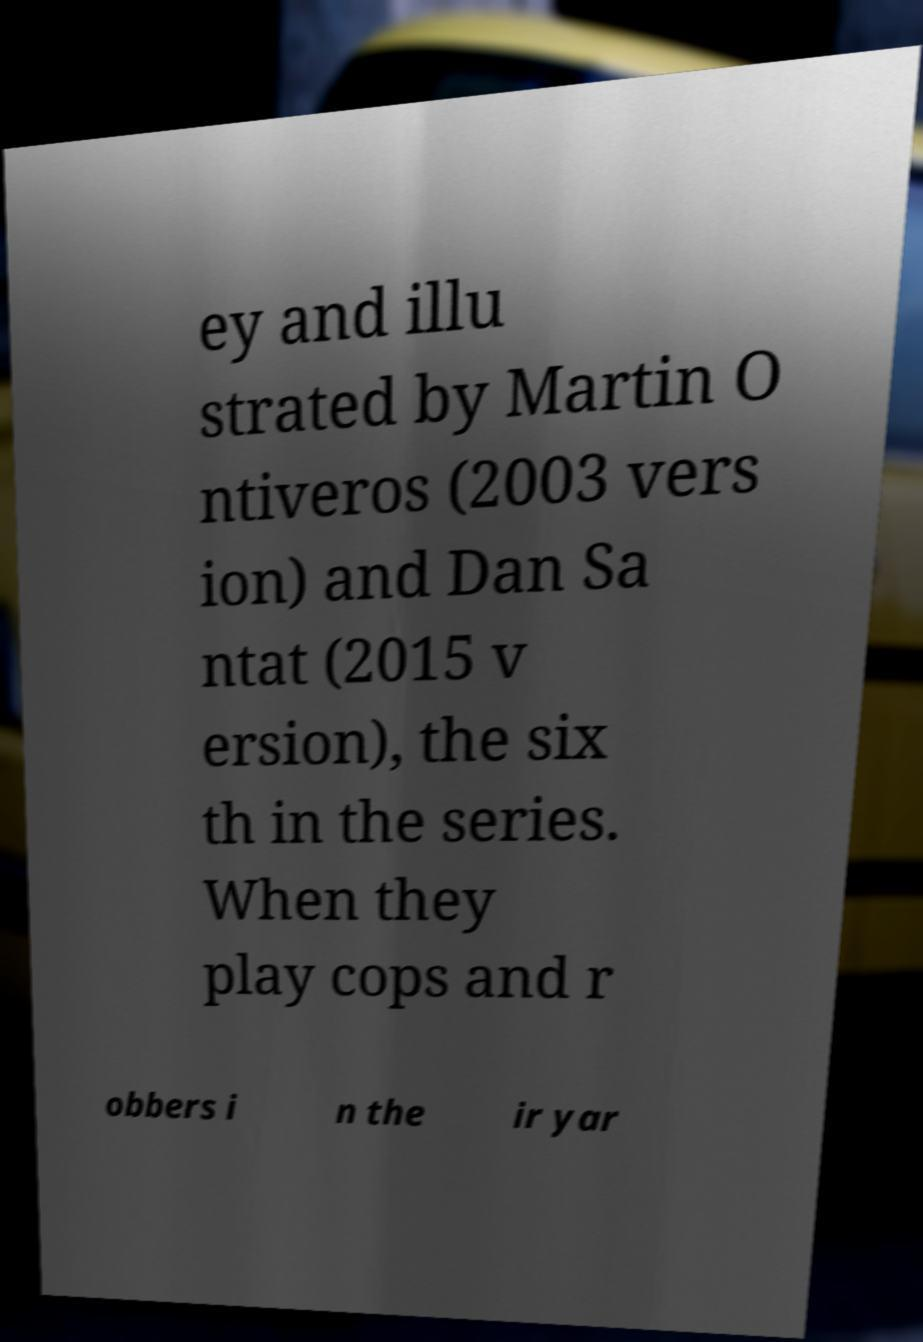Could you assist in decoding the text presented in this image and type it out clearly? ey and illu strated by Martin O ntiveros (2003 vers ion) and Dan Sa ntat (2015 v ersion), the six th in the series. When they play cops and r obbers i n the ir yar 